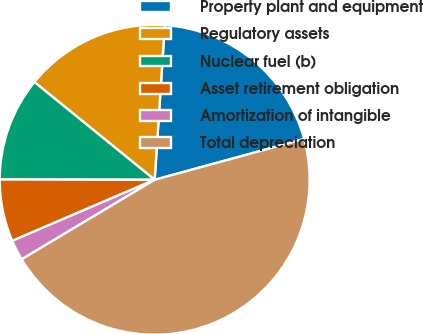Convert chart to OTSL. <chart><loc_0><loc_0><loc_500><loc_500><pie_chart><fcel>Property plant and equipment<fcel>Regulatory assets<fcel>Nuclear fuel (b)<fcel>Asset retirement obligation<fcel>Amortization of intangible<fcel>Total depreciation<nl><fcel>19.72%<fcel>15.18%<fcel>10.83%<fcel>6.48%<fcel>2.13%<fcel>45.66%<nl></chart> 